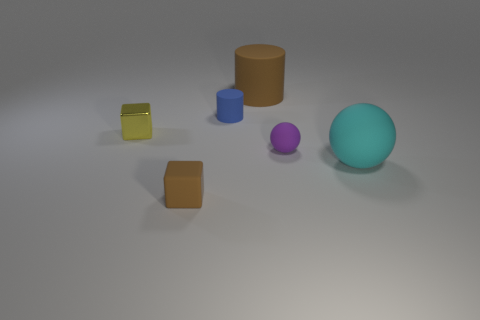Add 1 large red metal balls. How many objects exist? 7 Subtract 1 cylinders. How many cylinders are left? 1 Subtract all brown cylinders. How many cylinders are left? 1 Subtract all cyan rubber objects. Subtract all matte cylinders. How many objects are left? 3 Add 1 tiny brown rubber blocks. How many tiny brown rubber blocks are left? 2 Add 3 small purple spheres. How many small purple spheres exist? 4 Subtract 0 gray cylinders. How many objects are left? 6 Subtract all cylinders. How many objects are left? 4 Subtract all purple cylinders. Subtract all purple blocks. How many cylinders are left? 2 Subtract all brown cubes. How many blue cylinders are left? 1 